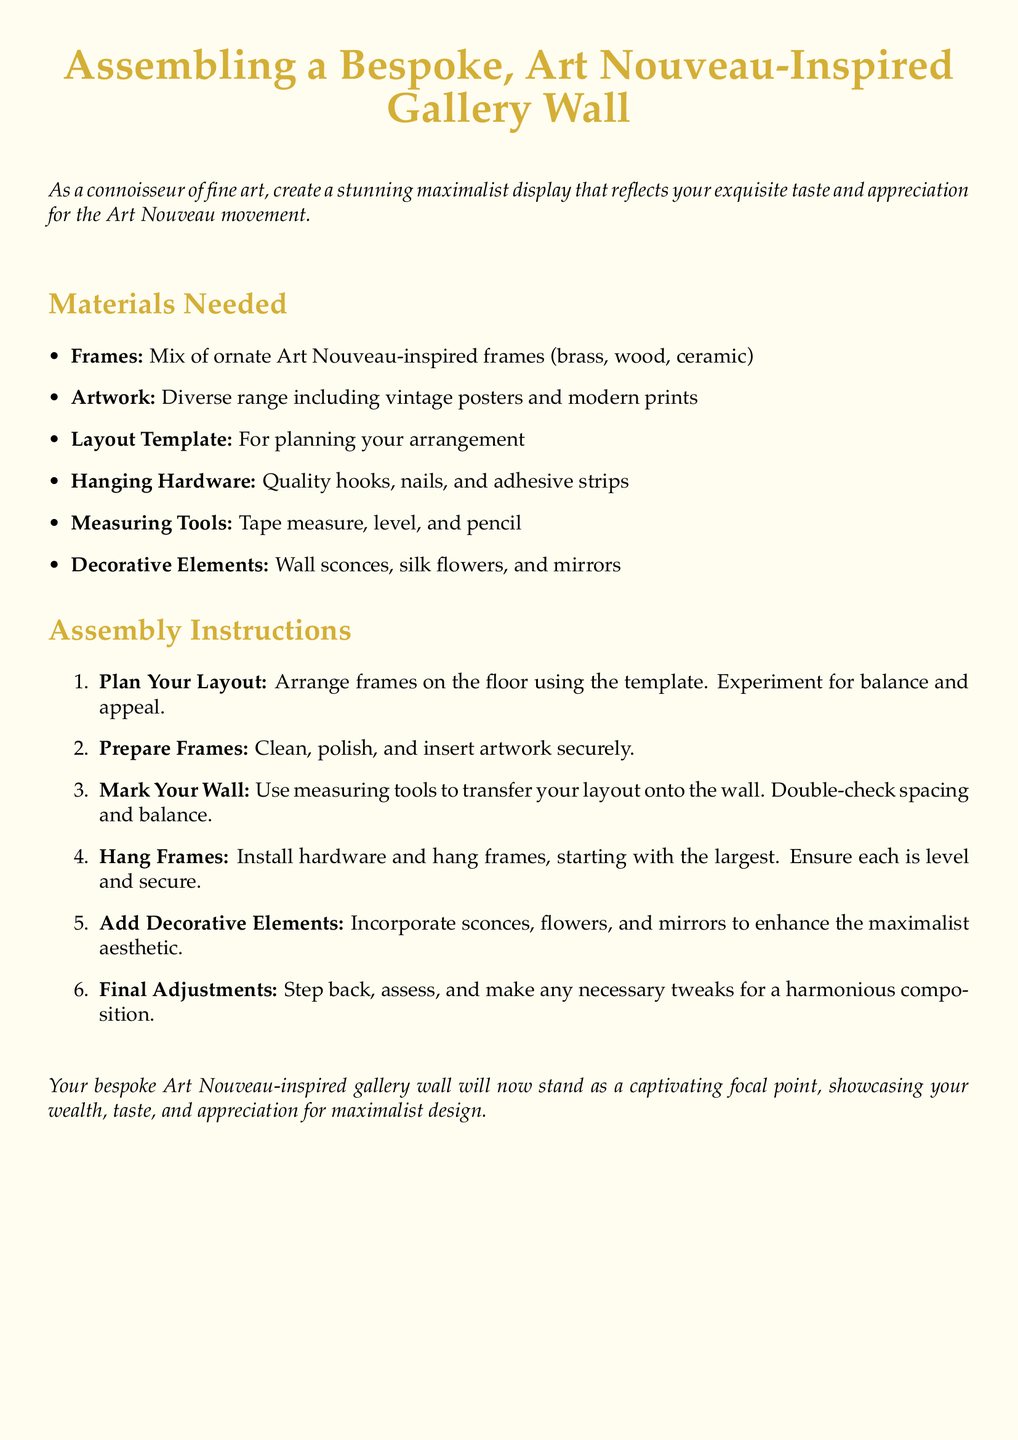What is the title of the document? The title is the main heading of the document, which is "Assembling a Bespoke, Art Nouveau-Inspired Gallery Wall".
Answer: Assembling a Bespoke, Art Nouveau-Inspired Gallery Wall How many types of frames are mentioned? The document lists three types of frames that are required: ornate Art Nouveau-inspired frames, brass, wood, and ceramic frames.
Answer: Three What is the first step in the assembly instructions? The first step is indicated in the assembly instructions and is "Plan Your Layout."
Answer: Plan Your Layout What decorative elements are suggested to enhance the aesthetic? The document specifies certain items to enhance the overall appearance of the gallery wall, namely wall sconces, silk flowers, and mirrors.
Answer: Wall sconces, silk flowers, and mirrors What should be used to mark the wall? The instructions recommend using measuring tools for marking the wall.
Answer: Measuring tools 